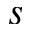Convert formula to latex. <formula><loc_0><loc_0><loc_500><loc_500>s</formula> 